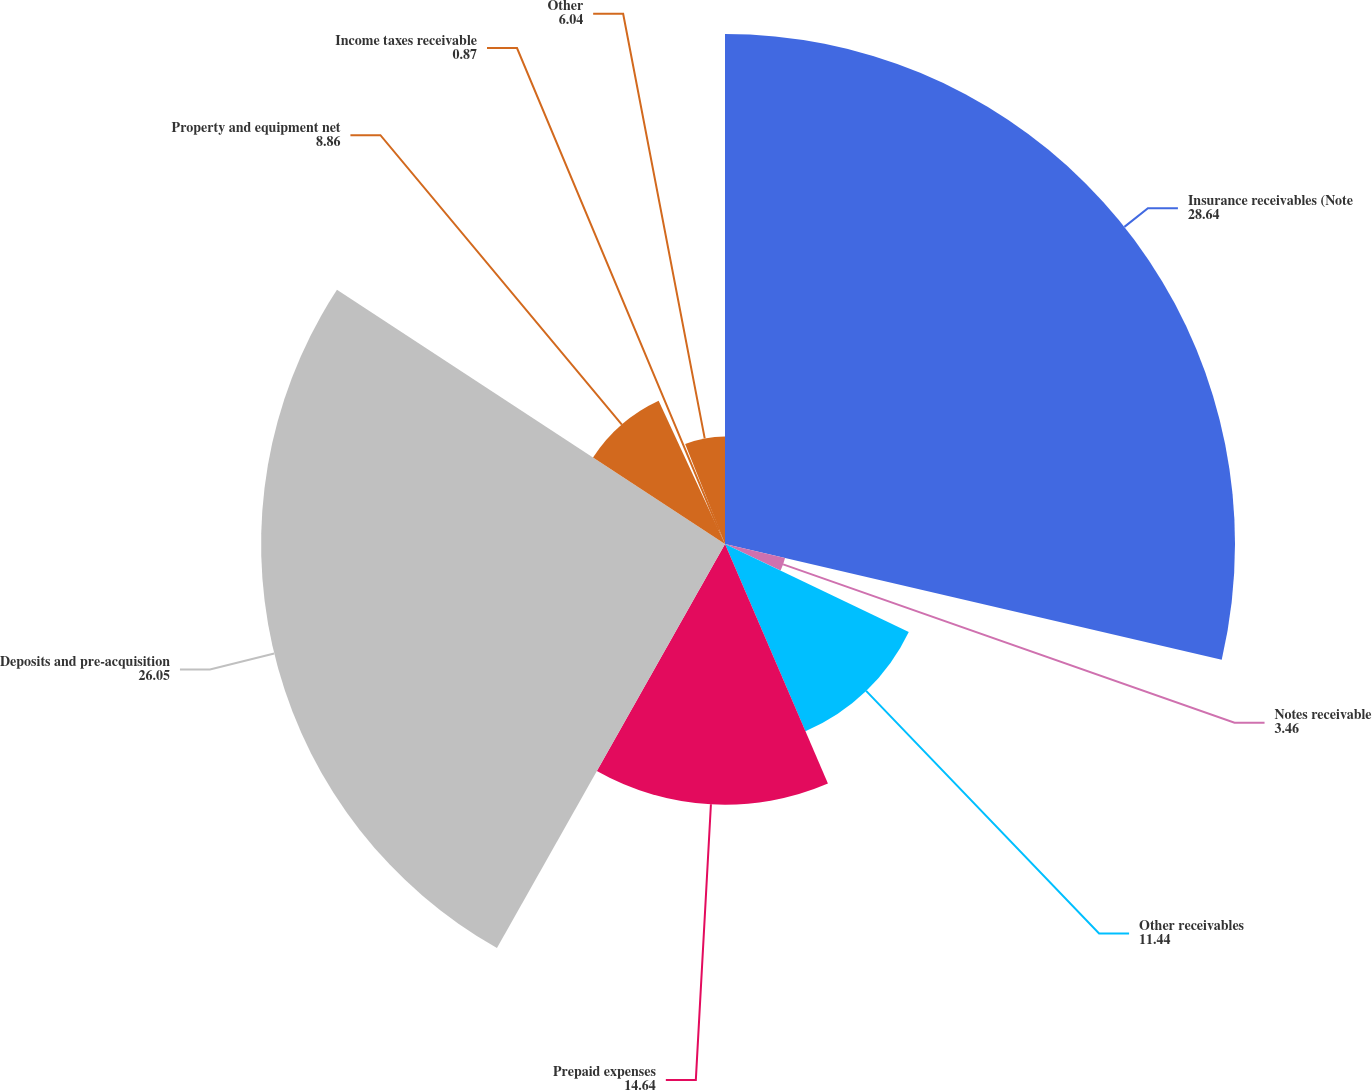Convert chart. <chart><loc_0><loc_0><loc_500><loc_500><pie_chart><fcel>Insurance receivables (Note<fcel>Notes receivable<fcel>Other receivables<fcel>Prepaid expenses<fcel>Deposits and pre-acquisition<fcel>Property and equipment net<fcel>Income taxes receivable<fcel>Other<nl><fcel>28.64%<fcel>3.46%<fcel>11.44%<fcel>14.64%<fcel>26.05%<fcel>8.86%<fcel>0.87%<fcel>6.04%<nl></chart> 